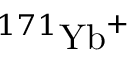<formula> <loc_0><loc_0><loc_500><loc_500>^ { 1 7 1 } { Y b } ^ { + }</formula> 